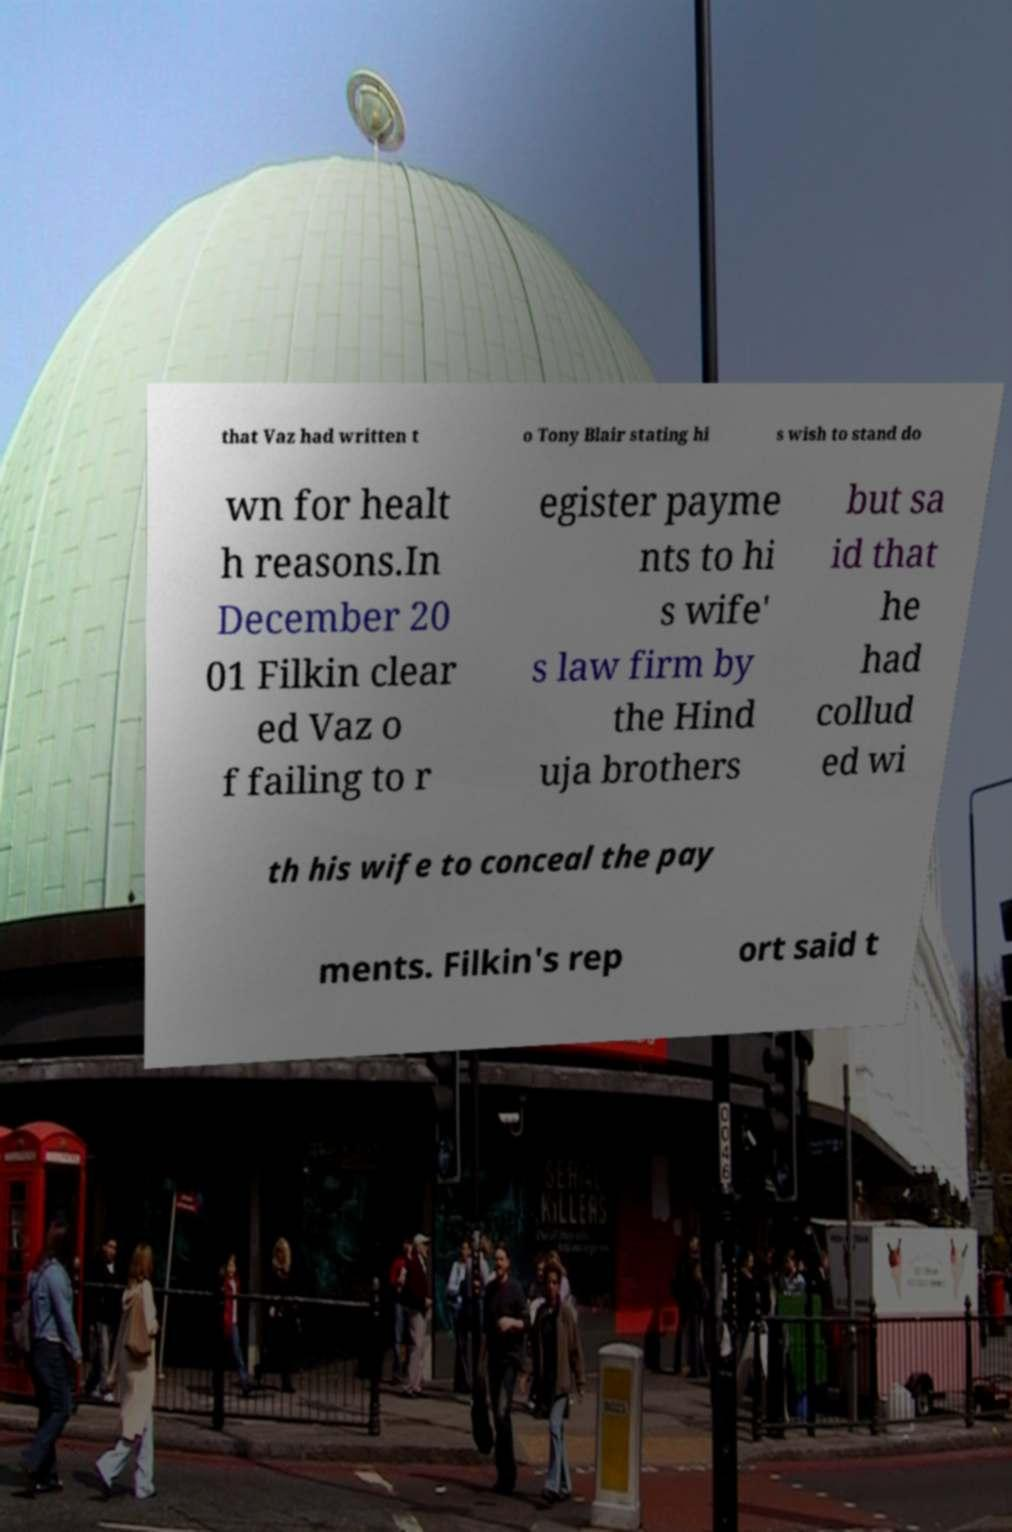Please read and relay the text visible in this image. What does it say? that Vaz had written t o Tony Blair stating hi s wish to stand do wn for healt h reasons.In December 20 01 Filkin clear ed Vaz o f failing to r egister payme nts to hi s wife' s law firm by the Hind uja brothers but sa id that he had collud ed wi th his wife to conceal the pay ments. Filkin's rep ort said t 